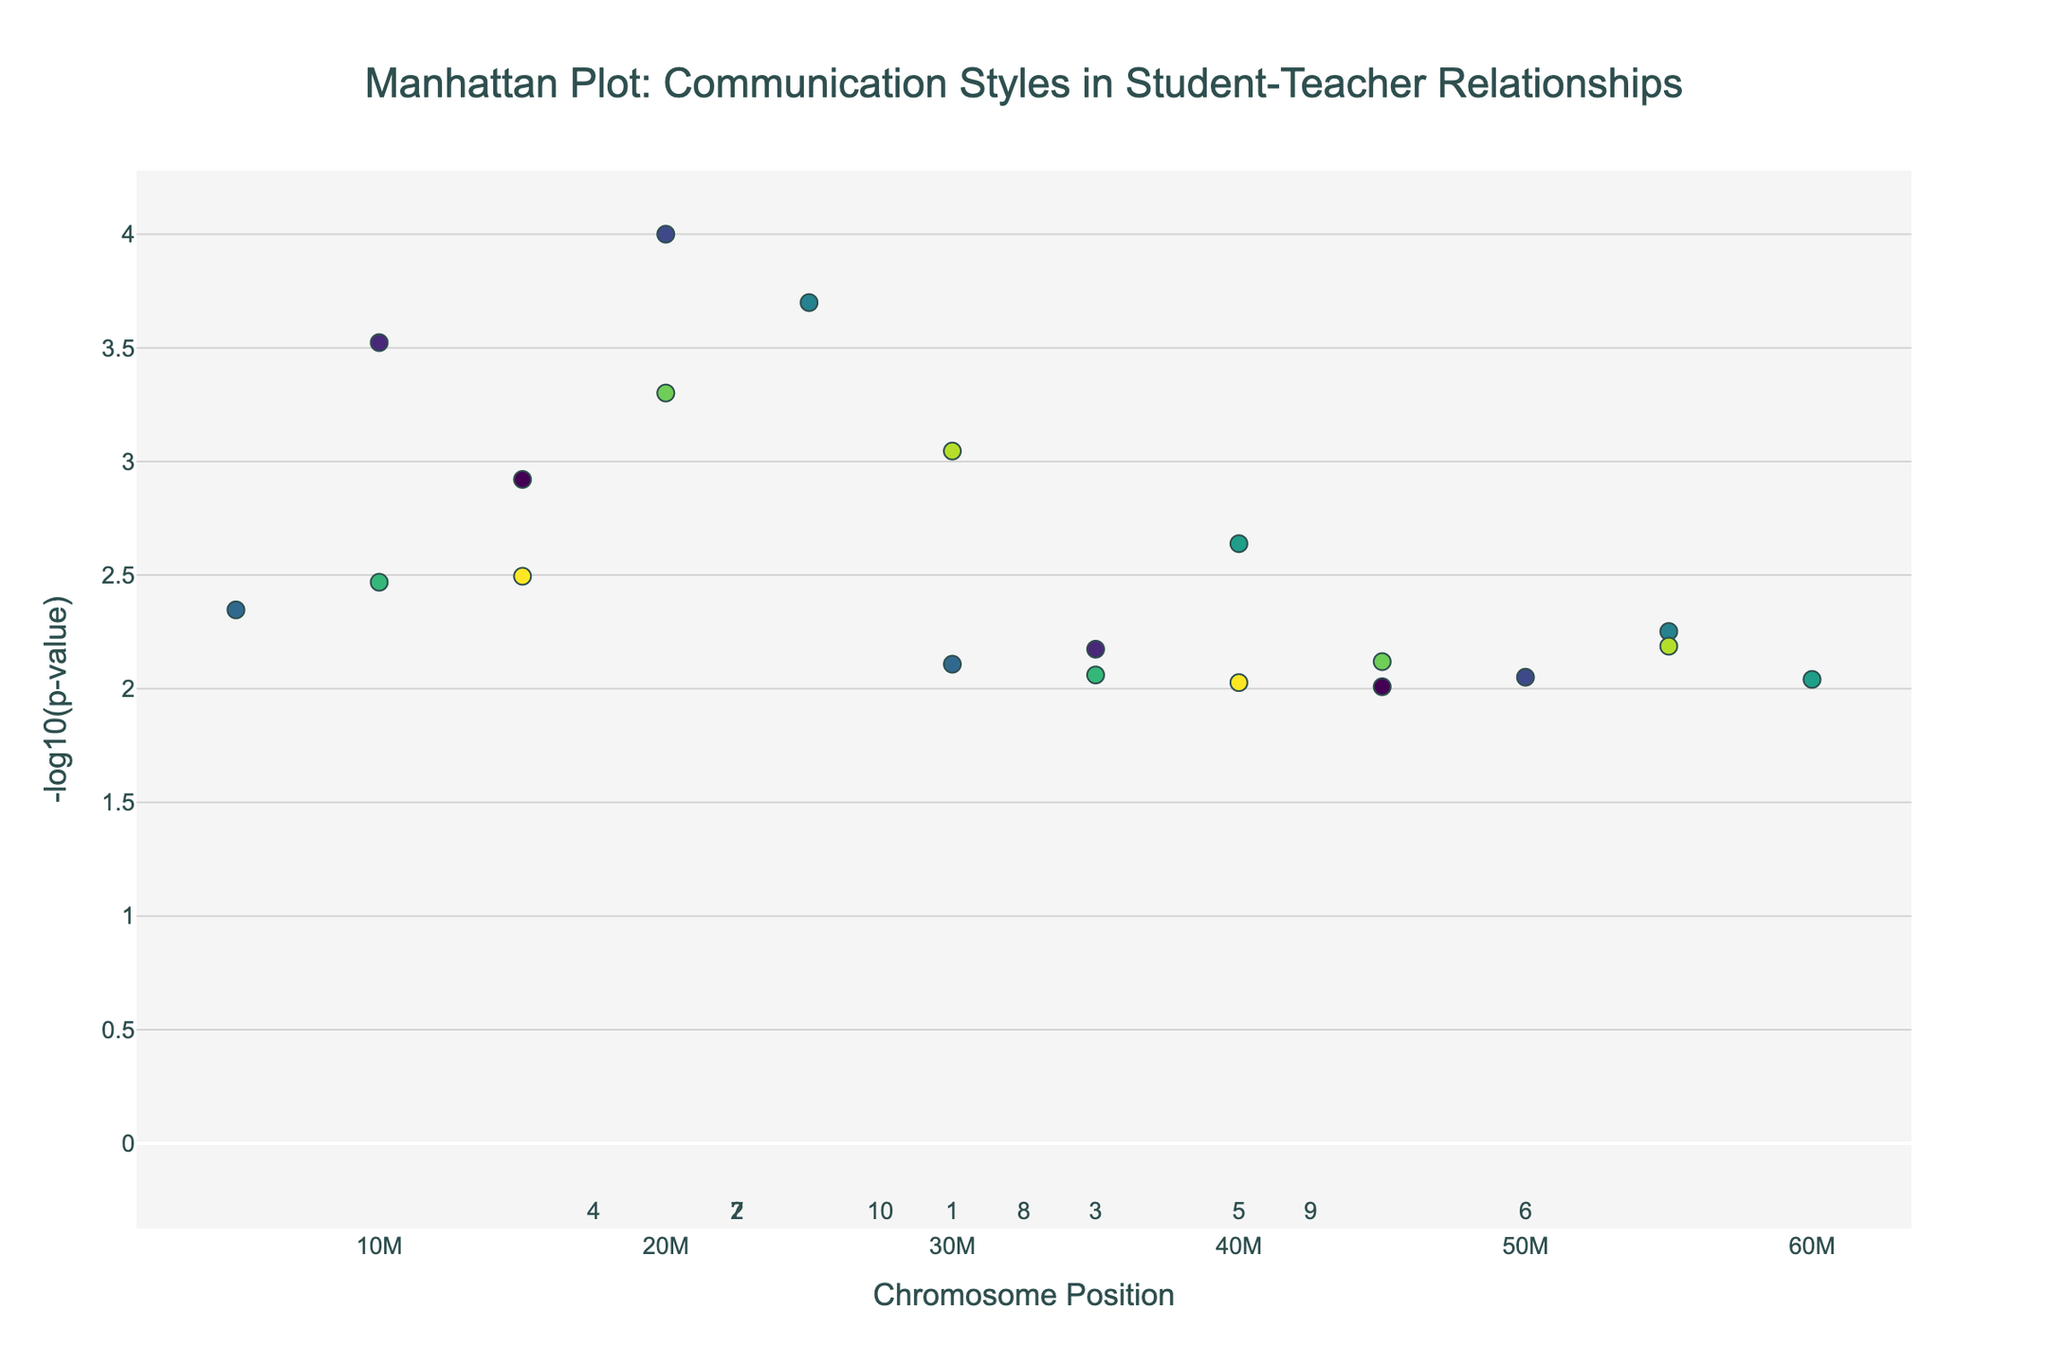How many different communication styles are plotted in the figure? To answer this, count the unique communication styles mentioned in the hover text or legend in the figure.
Answer: 18 What is the range of positions for Chromosome 3? Look at the horizontal axis positions specifically for Chromosome 3 and note the minimum and maximum positions. Chromosome 3 ranges from 20,000,000 to 50,000,000.
Answer: 20,000,000 to 50,000,000 Which communication style has the smallest p-value and on which chromosome is it located? Find the communication style with the highest -log10(p-value) on the vertical axis, then check its hover text or color legend for the corresponding communication style and chromosome information. Positive Reinforcement on Chromosome 3 has the smallest p-value.
Answer: Positive Reinforcement, Chromosome 3 Compare the -log10(p-value) of "Empathetic Responses" and "Growth Mindset Language". Which one is higher? Hover over or refer to the specific points for these communication styles and compare their vertical positions or -log10(p-values). "Growth Mindset Language" has a -log10(p-value) higher than "Empathetic Responses".
Answer: Growth Mindset Language What are the mean and median -log10(p-value) for the communication styles on Chromosome 5? Identify the -log10(p-values) for the two data points on Chromosome 5, calculate their mean and median. For Chromosome 5: -log10(0.0002) ≈ 3.70, -log10(0.0056) ≈ 2.25, mean = (3.70 + 2.25) / 2 ≈ 2.975, median = 2.975.
Answer: Mean: 2.975, Median: 2.975 How many communication styles have a p-value less than 0.001? Convert and count the points where -log10(p-value) is greater than or equal to 3 (since -log10(0.001) = 3). Six communication styles have p-values less than 0.001.
Answer: Six Which communication style on Chromosome 7 has a greater effect based on its -log10(p-value), "Mindfulness-based Interactions" or "Trauma-Informed Approach"? For Chromosome 7, compare the vertical axis values of "Mindfulness-based Interactions" and "Trauma-Informed Approach"; the higher value indicates a greater effect. "Mindfulness-based Interactions" has a higher -log10(p-value).
Answer: Mindfulness-based Interactions Calculate the difference in -log10(p-value) between "Restorative Practices" and "Culturally Responsive Communication". Look up the -log10(p-values) and subtract the smaller value from the larger one. For "Restorative Practices" (6, 60,000,000) ≈ 2.04 and "Culturally Responsive Communication" (6, 40,000,000) ≈ 2.64; difference ≈ 2.64 - 2.04 = 0.60.
Answer: 0.60 